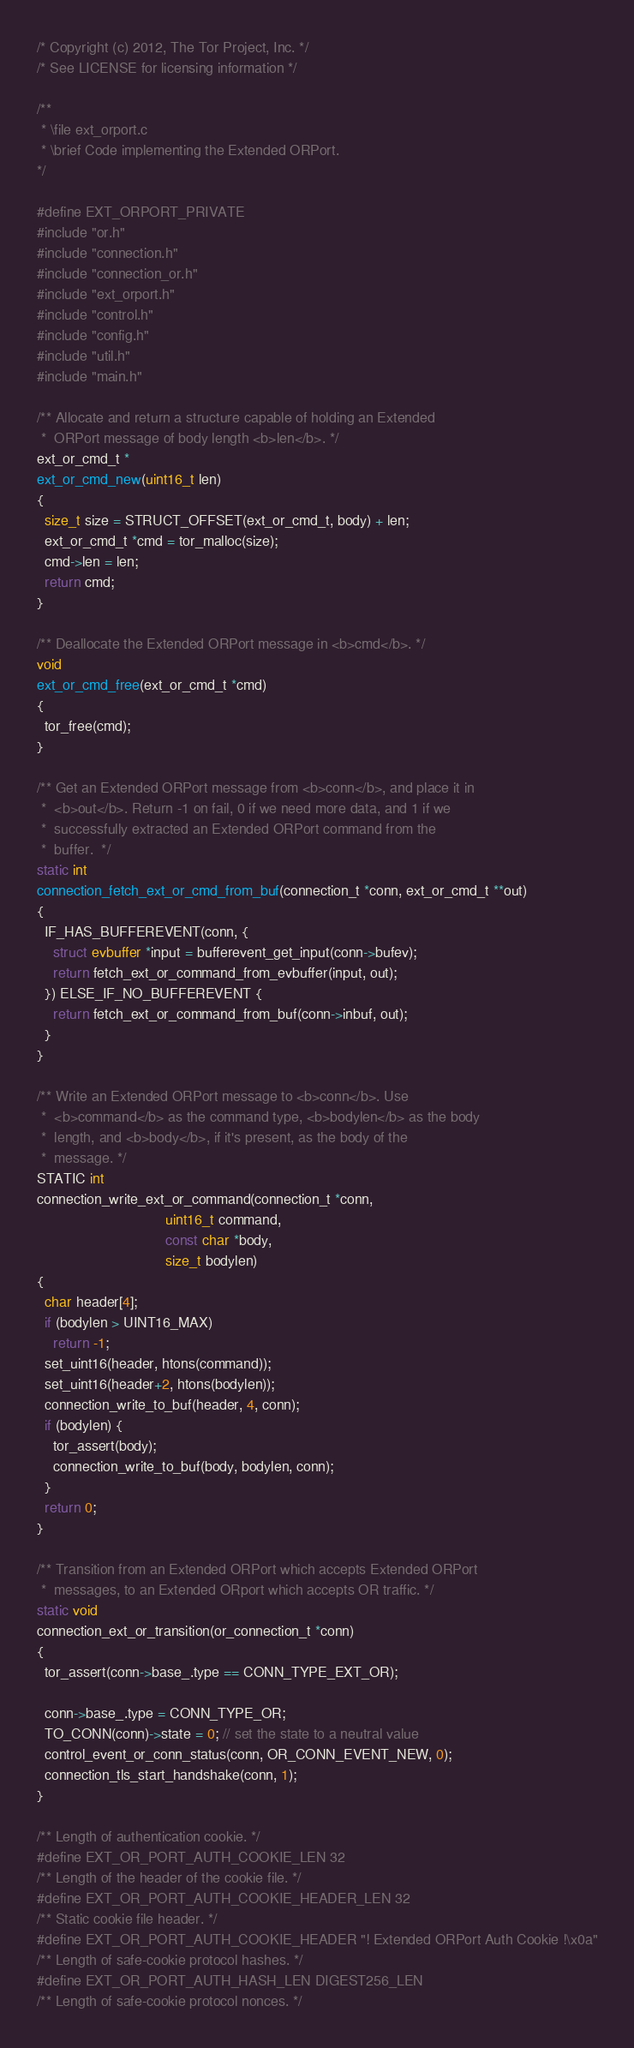Convert code to text. <code><loc_0><loc_0><loc_500><loc_500><_C_>/* Copyright (c) 2012, The Tor Project, Inc. */
/* See LICENSE for licensing information */

/**
 * \file ext_orport.c
 * \brief Code implementing the Extended ORPort.
*/

#define EXT_ORPORT_PRIVATE
#include "or.h"
#include "connection.h"
#include "connection_or.h"
#include "ext_orport.h"
#include "control.h"
#include "config.h"
#include "util.h"
#include "main.h"

/** Allocate and return a structure capable of holding an Extended
 *  ORPort message of body length <b>len</b>. */
ext_or_cmd_t *
ext_or_cmd_new(uint16_t len)
{
  size_t size = STRUCT_OFFSET(ext_or_cmd_t, body) + len;
  ext_or_cmd_t *cmd = tor_malloc(size);
  cmd->len = len;
  return cmd;
}

/** Deallocate the Extended ORPort message in <b>cmd</b>. */
void
ext_or_cmd_free(ext_or_cmd_t *cmd)
{
  tor_free(cmd);
}

/** Get an Extended ORPort message from <b>conn</b>, and place it in
 *  <b>out</b>. Return -1 on fail, 0 if we need more data, and 1 if we
 *  successfully extracted an Extended ORPort command from the
 *  buffer.  */
static int
connection_fetch_ext_or_cmd_from_buf(connection_t *conn, ext_or_cmd_t **out)
{
  IF_HAS_BUFFEREVENT(conn, {
    struct evbuffer *input = bufferevent_get_input(conn->bufev);
    return fetch_ext_or_command_from_evbuffer(input, out);
  }) ELSE_IF_NO_BUFFEREVENT {
    return fetch_ext_or_command_from_buf(conn->inbuf, out);
  }
}

/** Write an Extended ORPort message to <b>conn</b>. Use
 *  <b>command</b> as the command type, <b>bodylen</b> as the body
 *  length, and <b>body</b>, if it's present, as the body of the
 *  message. */
STATIC int
connection_write_ext_or_command(connection_t *conn,
                                uint16_t command,
                                const char *body,
                                size_t bodylen)
{
  char header[4];
  if (bodylen > UINT16_MAX)
    return -1;
  set_uint16(header, htons(command));
  set_uint16(header+2, htons(bodylen));
  connection_write_to_buf(header, 4, conn);
  if (bodylen) {
    tor_assert(body);
    connection_write_to_buf(body, bodylen, conn);
  }
  return 0;
}

/** Transition from an Extended ORPort which accepts Extended ORPort
 *  messages, to an Extended ORport which accepts OR traffic. */
static void
connection_ext_or_transition(or_connection_t *conn)
{
  tor_assert(conn->base_.type == CONN_TYPE_EXT_OR);

  conn->base_.type = CONN_TYPE_OR;
  TO_CONN(conn)->state = 0; // set the state to a neutral value
  control_event_or_conn_status(conn, OR_CONN_EVENT_NEW, 0);
  connection_tls_start_handshake(conn, 1);
}

/** Length of authentication cookie. */
#define EXT_OR_PORT_AUTH_COOKIE_LEN 32
/** Length of the header of the cookie file. */
#define EXT_OR_PORT_AUTH_COOKIE_HEADER_LEN 32
/** Static cookie file header. */
#define EXT_OR_PORT_AUTH_COOKIE_HEADER "! Extended ORPort Auth Cookie !\x0a"
/** Length of safe-cookie protocol hashes. */
#define EXT_OR_PORT_AUTH_HASH_LEN DIGEST256_LEN
/** Length of safe-cookie protocol nonces. */</code> 